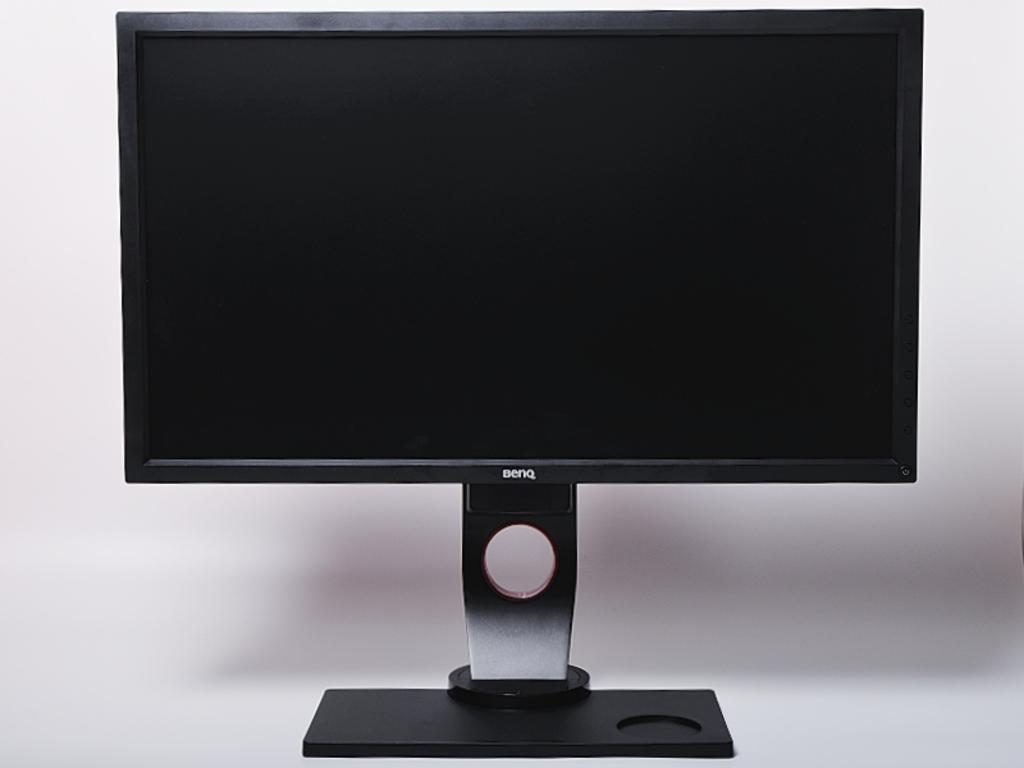<image>
Offer a succinct explanation of the picture presented. The front side of a BENQ computer monitor 